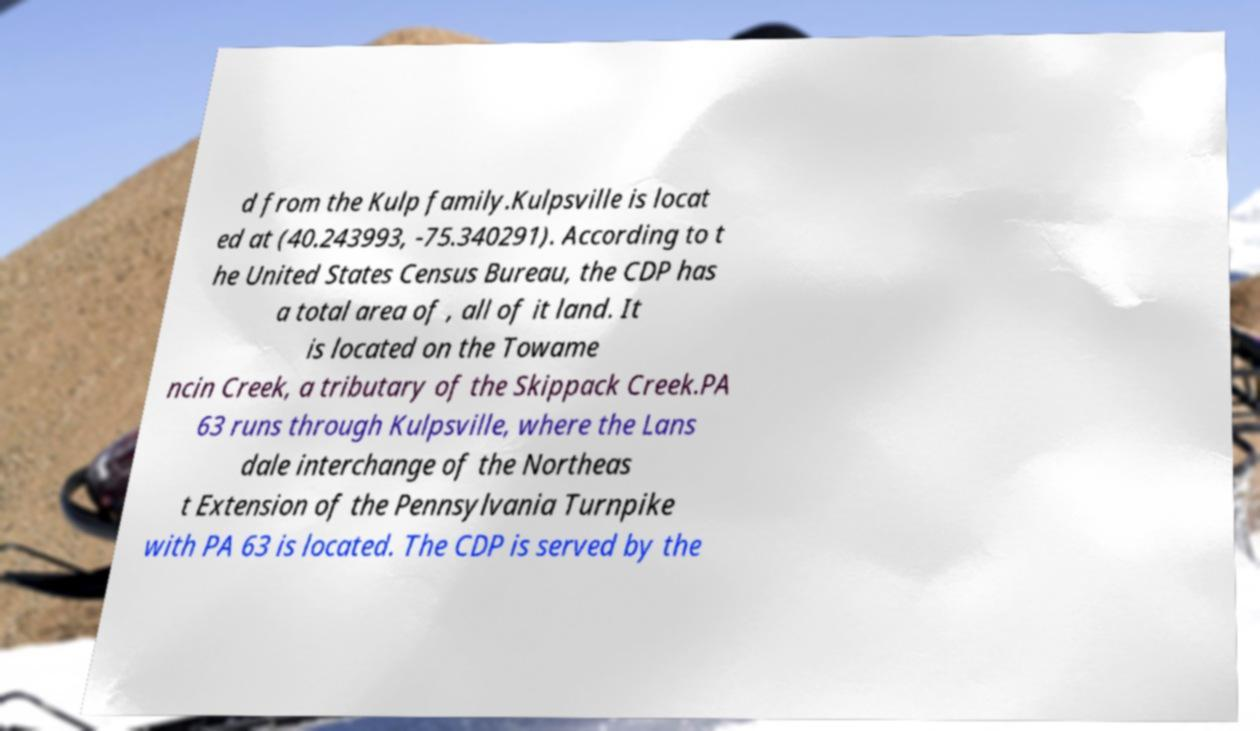Can you accurately transcribe the text from the provided image for me? d from the Kulp family.Kulpsville is locat ed at (40.243993, -75.340291). According to t he United States Census Bureau, the CDP has a total area of , all of it land. It is located on the Towame ncin Creek, a tributary of the Skippack Creek.PA 63 runs through Kulpsville, where the Lans dale interchange of the Northeas t Extension of the Pennsylvania Turnpike with PA 63 is located. The CDP is served by the 